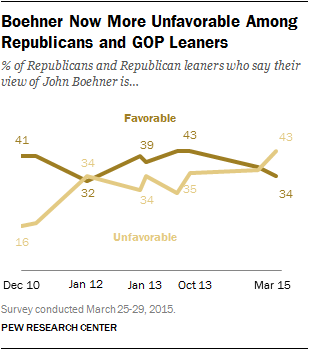Specify some key components in this picture. On March 15th, the value of the favorable graph was 34. The unfavorable graph values are combined to determine if the total is less than or equal to 35. If the total is greater than the highest value of the favorable graph, then the answer is yes. 